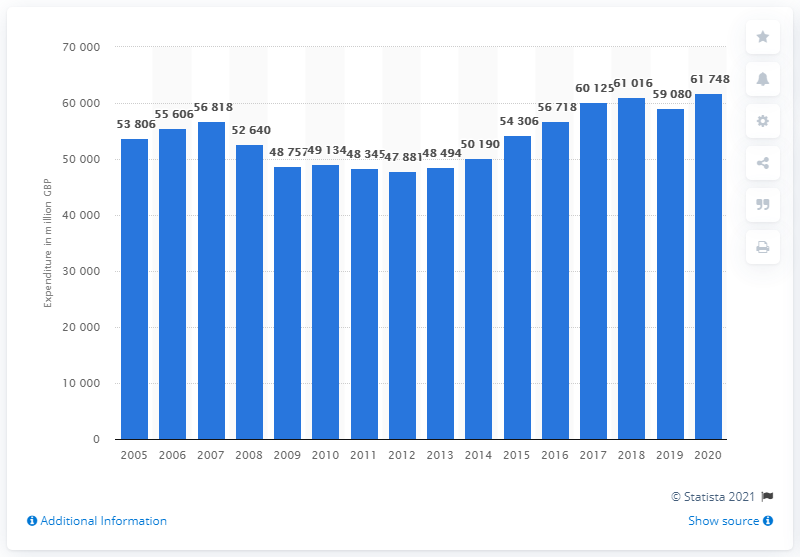Specify some key components in this picture. In 2020, UK households purchased approximately 61,748 pounds worth of household equipment. 